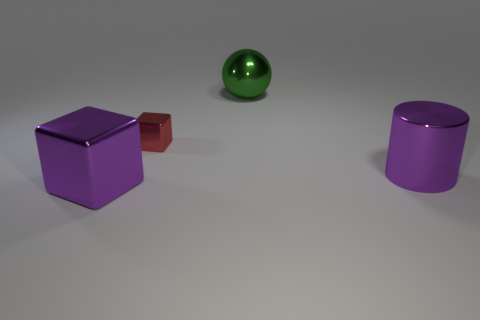Add 3 large purple metallic blocks. How many objects exist? 7 Subtract all cylinders. How many objects are left? 3 Add 4 big purple matte blocks. How many big purple matte blocks exist? 4 Subtract 1 purple blocks. How many objects are left? 3 Subtract all purple objects. Subtract all red metallic blocks. How many objects are left? 1 Add 4 big objects. How many big objects are left? 7 